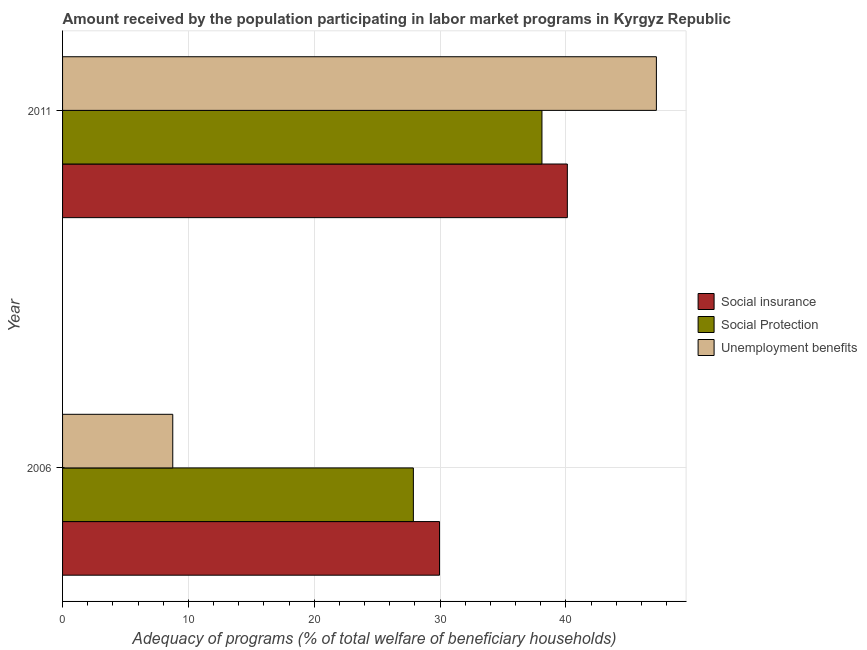How many groups of bars are there?
Your response must be concise. 2. Are the number of bars per tick equal to the number of legend labels?
Provide a succinct answer. Yes. How many bars are there on the 1st tick from the top?
Offer a very short reply. 3. How many bars are there on the 1st tick from the bottom?
Your answer should be compact. 3. What is the label of the 1st group of bars from the top?
Your response must be concise. 2011. What is the amount received by the population participating in social protection programs in 2011?
Your response must be concise. 38.1. Across all years, what is the maximum amount received by the population participating in social protection programs?
Your answer should be compact. 38.1. Across all years, what is the minimum amount received by the population participating in unemployment benefits programs?
Make the answer very short. 8.76. In which year was the amount received by the population participating in unemployment benefits programs minimum?
Your response must be concise. 2006. What is the total amount received by the population participating in social insurance programs in the graph?
Keep it short and to the point. 70.07. What is the difference between the amount received by the population participating in social insurance programs in 2006 and that in 2011?
Offer a terse response. -10.16. What is the difference between the amount received by the population participating in social insurance programs in 2006 and the amount received by the population participating in social protection programs in 2011?
Give a very brief answer. -8.14. What is the average amount received by the population participating in unemployment benefits programs per year?
Your answer should be compact. 27.98. In the year 2006, what is the difference between the amount received by the population participating in social protection programs and amount received by the population participating in unemployment benefits programs?
Your answer should be very brief. 19.12. What is the ratio of the amount received by the population participating in social protection programs in 2006 to that in 2011?
Ensure brevity in your answer.  0.73. Is the amount received by the population participating in social protection programs in 2006 less than that in 2011?
Your answer should be very brief. Yes. Is the difference between the amount received by the population participating in social protection programs in 2006 and 2011 greater than the difference between the amount received by the population participating in unemployment benefits programs in 2006 and 2011?
Provide a succinct answer. Yes. In how many years, is the amount received by the population participating in unemployment benefits programs greater than the average amount received by the population participating in unemployment benefits programs taken over all years?
Give a very brief answer. 1. What does the 2nd bar from the top in 2011 represents?
Give a very brief answer. Social Protection. What does the 3rd bar from the bottom in 2011 represents?
Give a very brief answer. Unemployment benefits. How many bars are there?
Offer a very short reply. 6. What is the difference between two consecutive major ticks on the X-axis?
Provide a short and direct response. 10. Are the values on the major ticks of X-axis written in scientific E-notation?
Provide a succinct answer. No. Does the graph contain any zero values?
Your answer should be compact. No. Does the graph contain grids?
Your answer should be very brief. Yes. Where does the legend appear in the graph?
Make the answer very short. Center right. How many legend labels are there?
Your answer should be compact. 3. How are the legend labels stacked?
Keep it short and to the point. Vertical. What is the title of the graph?
Make the answer very short. Amount received by the population participating in labor market programs in Kyrgyz Republic. Does "Coal" appear as one of the legend labels in the graph?
Your answer should be compact. No. What is the label or title of the X-axis?
Provide a short and direct response. Adequacy of programs (% of total welfare of beneficiary households). What is the Adequacy of programs (% of total welfare of beneficiary households) of Social insurance in 2006?
Give a very brief answer. 29.96. What is the Adequacy of programs (% of total welfare of beneficiary households) of Social Protection in 2006?
Your answer should be very brief. 27.88. What is the Adequacy of programs (% of total welfare of beneficiary households) of Unemployment benefits in 2006?
Your answer should be compact. 8.76. What is the Adequacy of programs (% of total welfare of beneficiary households) in Social insurance in 2011?
Offer a very short reply. 40.12. What is the Adequacy of programs (% of total welfare of beneficiary households) of Social Protection in 2011?
Offer a very short reply. 38.1. What is the Adequacy of programs (% of total welfare of beneficiary households) of Unemployment benefits in 2011?
Offer a very short reply. 47.19. Across all years, what is the maximum Adequacy of programs (% of total welfare of beneficiary households) in Social insurance?
Your answer should be compact. 40.12. Across all years, what is the maximum Adequacy of programs (% of total welfare of beneficiary households) in Social Protection?
Your answer should be very brief. 38.1. Across all years, what is the maximum Adequacy of programs (% of total welfare of beneficiary households) in Unemployment benefits?
Your answer should be compact. 47.19. Across all years, what is the minimum Adequacy of programs (% of total welfare of beneficiary households) in Social insurance?
Offer a very short reply. 29.96. Across all years, what is the minimum Adequacy of programs (% of total welfare of beneficiary households) in Social Protection?
Provide a succinct answer. 27.88. Across all years, what is the minimum Adequacy of programs (% of total welfare of beneficiary households) of Unemployment benefits?
Your answer should be compact. 8.76. What is the total Adequacy of programs (% of total welfare of beneficiary households) in Social insurance in the graph?
Give a very brief answer. 70.07. What is the total Adequacy of programs (% of total welfare of beneficiary households) in Social Protection in the graph?
Your answer should be very brief. 65.98. What is the total Adequacy of programs (% of total welfare of beneficiary households) in Unemployment benefits in the graph?
Your answer should be compact. 55.95. What is the difference between the Adequacy of programs (% of total welfare of beneficiary households) in Social insurance in 2006 and that in 2011?
Offer a very short reply. -10.16. What is the difference between the Adequacy of programs (% of total welfare of beneficiary households) in Social Protection in 2006 and that in 2011?
Provide a succinct answer. -10.22. What is the difference between the Adequacy of programs (% of total welfare of beneficiary households) in Unemployment benefits in 2006 and that in 2011?
Your response must be concise. -38.43. What is the difference between the Adequacy of programs (% of total welfare of beneficiary households) of Social insurance in 2006 and the Adequacy of programs (% of total welfare of beneficiary households) of Social Protection in 2011?
Offer a very short reply. -8.14. What is the difference between the Adequacy of programs (% of total welfare of beneficiary households) in Social insurance in 2006 and the Adequacy of programs (% of total welfare of beneficiary households) in Unemployment benefits in 2011?
Offer a very short reply. -17.24. What is the difference between the Adequacy of programs (% of total welfare of beneficiary households) of Social Protection in 2006 and the Adequacy of programs (% of total welfare of beneficiary households) of Unemployment benefits in 2011?
Your answer should be compact. -19.31. What is the average Adequacy of programs (% of total welfare of beneficiary households) in Social insurance per year?
Give a very brief answer. 35.04. What is the average Adequacy of programs (% of total welfare of beneficiary households) in Social Protection per year?
Ensure brevity in your answer.  32.99. What is the average Adequacy of programs (% of total welfare of beneficiary households) in Unemployment benefits per year?
Make the answer very short. 27.98. In the year 2006, what is the difference between the Adequacy of programs (% of total welfare of beneficiary households) in Social insurance and Adequacy of programs (% of total welfare of beneficiary households) in Social Protection?
Your answer should be compact. 2.08. In the year 2006, what is the difference between the Adequacy of programs (% of total welfare of beneficiary households) in Social insurance and Adequacy of programs (% of total welfare of beneficiary households) in Unemployment benefits?
Your response must be concise. 21.2. In the year 2006, what is the difference between the Adequacy of programs (% of total welfare of beneficiary households) in Social Protection and Adequacy of programs (% of total welfare of beneficiary households) in Unemployment benefits?
Keep it short and to the point. 19.12. In the year 2011, what is the difference between the Adequacy of programs (% of total welfare of beneficiary households) of Social insurance and Adequacy of programs (% of total welfare of beneficiary households) of Social Protection?
Make the answer very short. 2.02. In the year 2011, what is the difference between the Adequacy of programs (% of total welfare of beneficiary households) of Social insurance and Adequacy of programs (% of total welfare of beneficiary households) of Unemployment benefits?
Offer a very short reply. -7.08. In the year 2011, what is the difference between the Adequacy of programs (% of total welfare of beneficiary households) in Social Protection and Adequacy of programs (% of total welfare of beneficiary households) in Unemployment benefits?
Give a very brief answer. -9.09. What is the ratio of the Adequacy of programs (% of total welfare of beneficiary households) in Social insurance in 2006 to that in 2011?
Make the answer very short. 0.75. What is the ratio of the Adequacy of programs (% of total welfare of beneficiary households) in Social Protection in 2006 to that in 2011?
Your answer should be compact. 0.73. What is the ratio of the Adequacy of programs (% of total welfare of beneficiary households) of Unemployment benefits in 2006 to that in 2011?
Your answer should be compact. 0.19. What is the difference between the highest and the second highest Adequacy of programs (% of total welfare of beneficiary households) of Social insurance?
Make the answer very short. 10.16. What is the difference between the highest and the second highest Adequacy of programs (% of total welfare of beneficiary households) in Social Protection?
Make the answer very short. 10.22. What is the difference between the highest and the second highest Adequacy of programs (% of total welfare of beneficiary households) of Unemployment benefits?
Make the answer very short. 38.43. What is the difference between the highest and the lowest Adequacy of programs (% of total welfare of beneficiary households) in Social insurance?
Provide a succinct answer. 10.16. What is the difference between the highest and the lowest Adequacy of programs (% of total welfare of beneficiary households) in Social Protection?
Provide a short and direct response. 10.22. What is the difference between the highest and the lowest Adequacy of programs (% of total welfare of beneficiary households) of Unemployment benefits?
Your answer should be very brief. 38.43. 